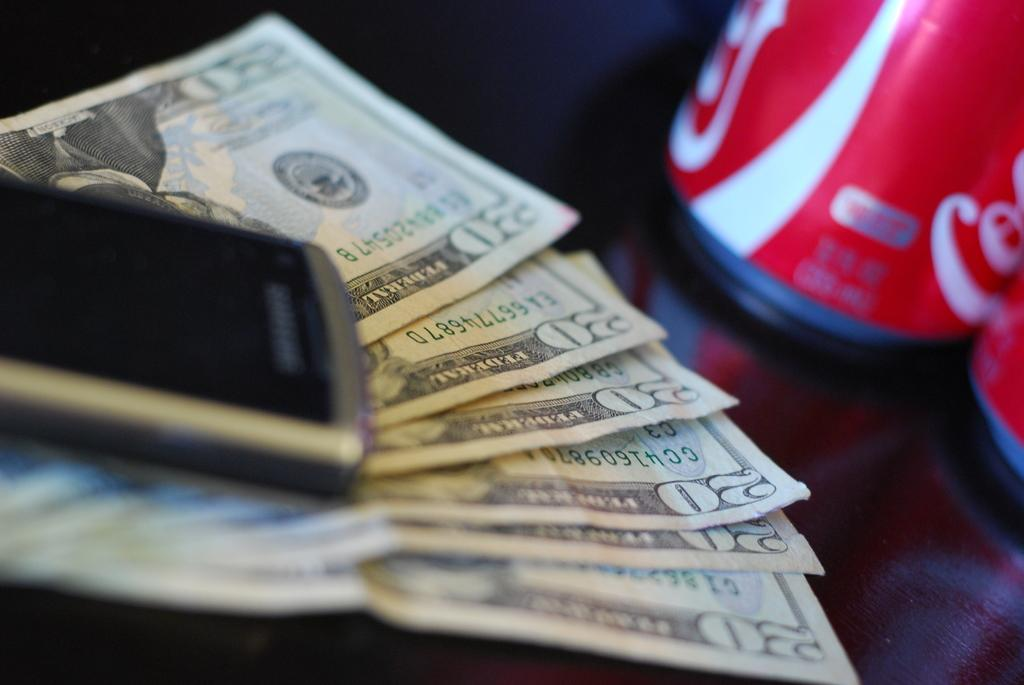<image>
Render a clear and concise summary of the photo. A cell phone rests on $120 and next to some Coke cans. 